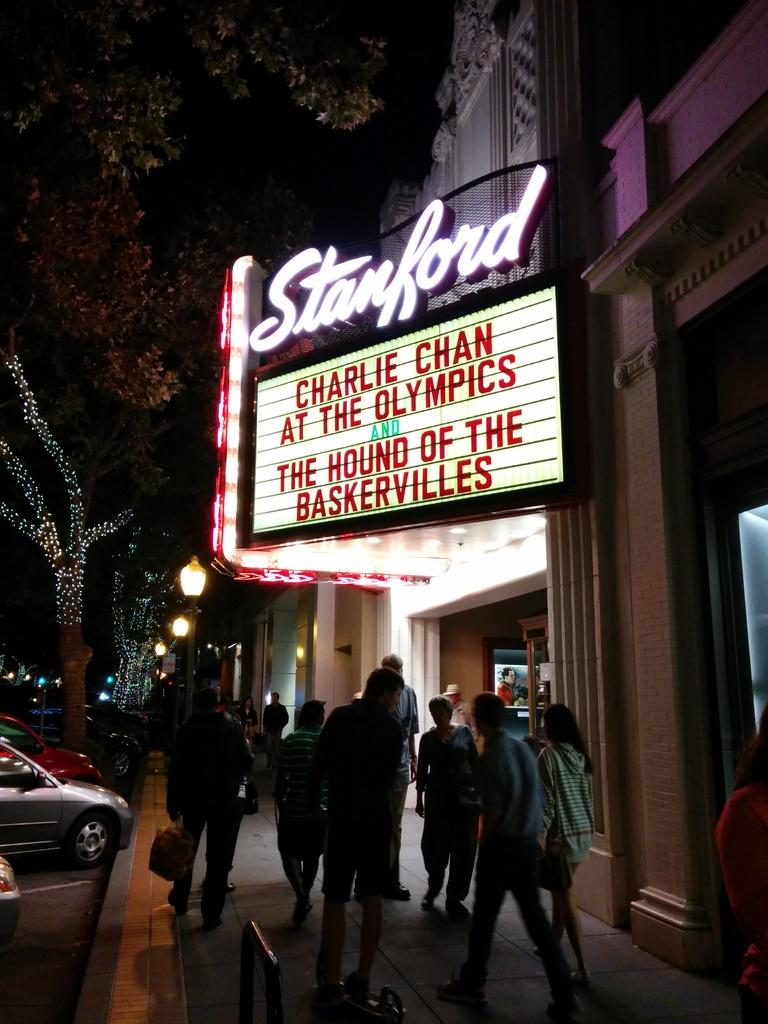What are the people in the image doing? The people in the image are standing on the walkway. What can be seen in the parking space? There are vehicles in the parking space. What type of natural elements are visible in the image? Trees are visible in the image. What additional features can be seen in the image? Decorative lights and a hoarding are present. What type of gold object is hanging from the trees in the image? There is no gold object present in the image; it only features people, vehicles, trees, decorative lights, and a hoarding. Can you tell me how many pens are visible in the image? There are no pens visible in the image. 